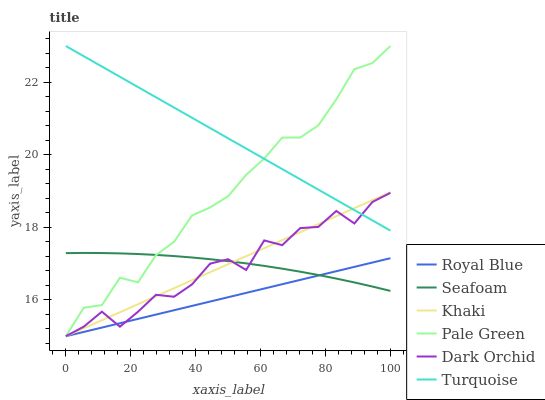Does Khaki have the minimum area under the curve?
Answer yes or no. No. Does Khaki have the maximum area under the curve?
Answer yes or no. No. Is Khaki the smoothest?
Answer yes or no. No. Is Khaki the roughest?
Answer yes or no. No. Does Seafoam have the lowest value?
Answer yes or no. No. Does Khaki have the highest value?
Answer yes or no. No. Is Royal Blue less than Turquoise?
Answer yes or no. Yes. Is Turquoise greater than Royal Blue?
Answer yes or no. Yes. Does Royal Blue intersect Turquoise?
Answer yes or no. No. 